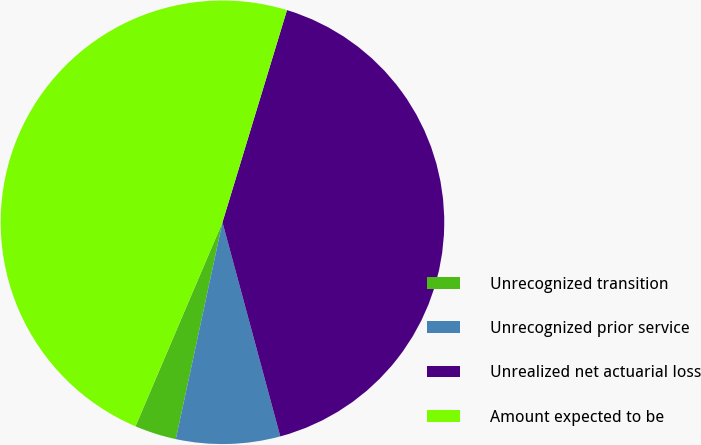Convert chart. <chart><loc_0><loc_0><loc_500><loc_500><pie_chart><fcel>Unrecognized transition<fcel>Unrecognized prior service<fcel>Unrealized net actuarial loss<fcel>Amount expected to be<nl><fcel>3.04%<fcel>7.57%<fcel>41.1%<fcel>48.28%<nl></chart> 